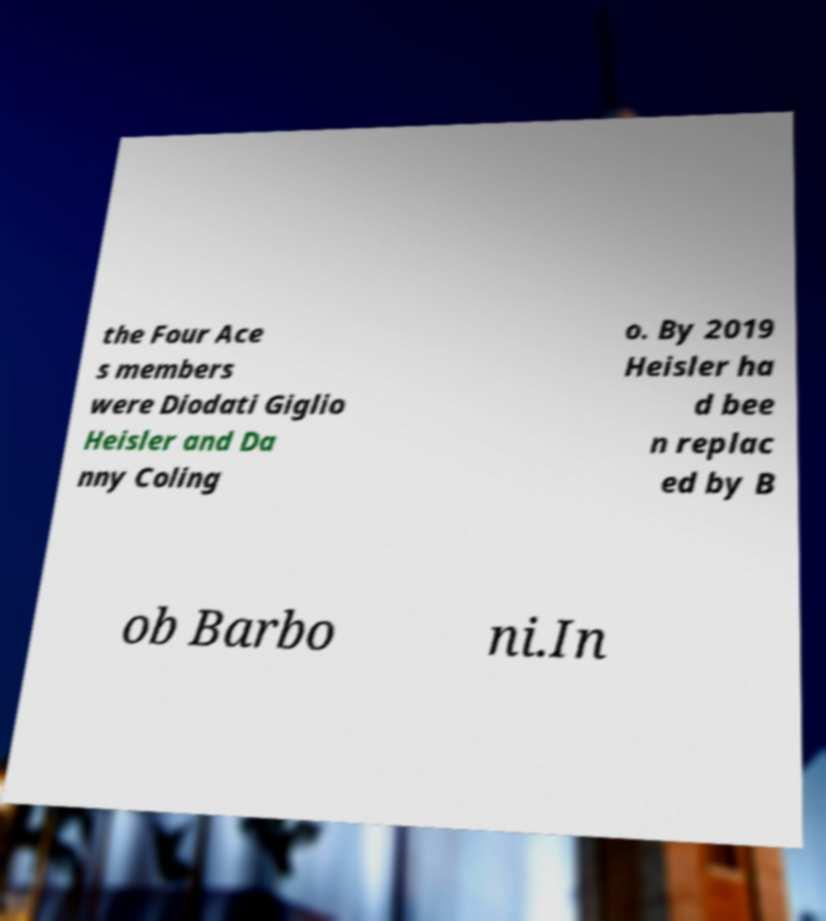What messages or text are displayed in this image? I need them in a readable, typed format. the Four Ace s members were Diodati Giglio Heisler and Da nny Coling o. By 2019 Heisler ha d bee n replac ed by B ob Barbo ni.In 